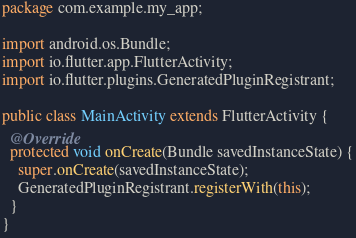<code> <loc_0><loc_0><loc_500><loc_500><_Java_>package com.example.my_app;

import android.os.Bundle;
import io.flutter.app.FlutterActivity;
import io.flutter.plugins.GeneratedPluginRegistrant;

public class MainActivity extends FlutterActivity {
  @Override
  protected void onCreate(Bundle savedInstanceState) {
    super.onCreate(savedInstanceState);
    GeneratedPluginRegistrant.registerWith(this);
  }
}
</code> 